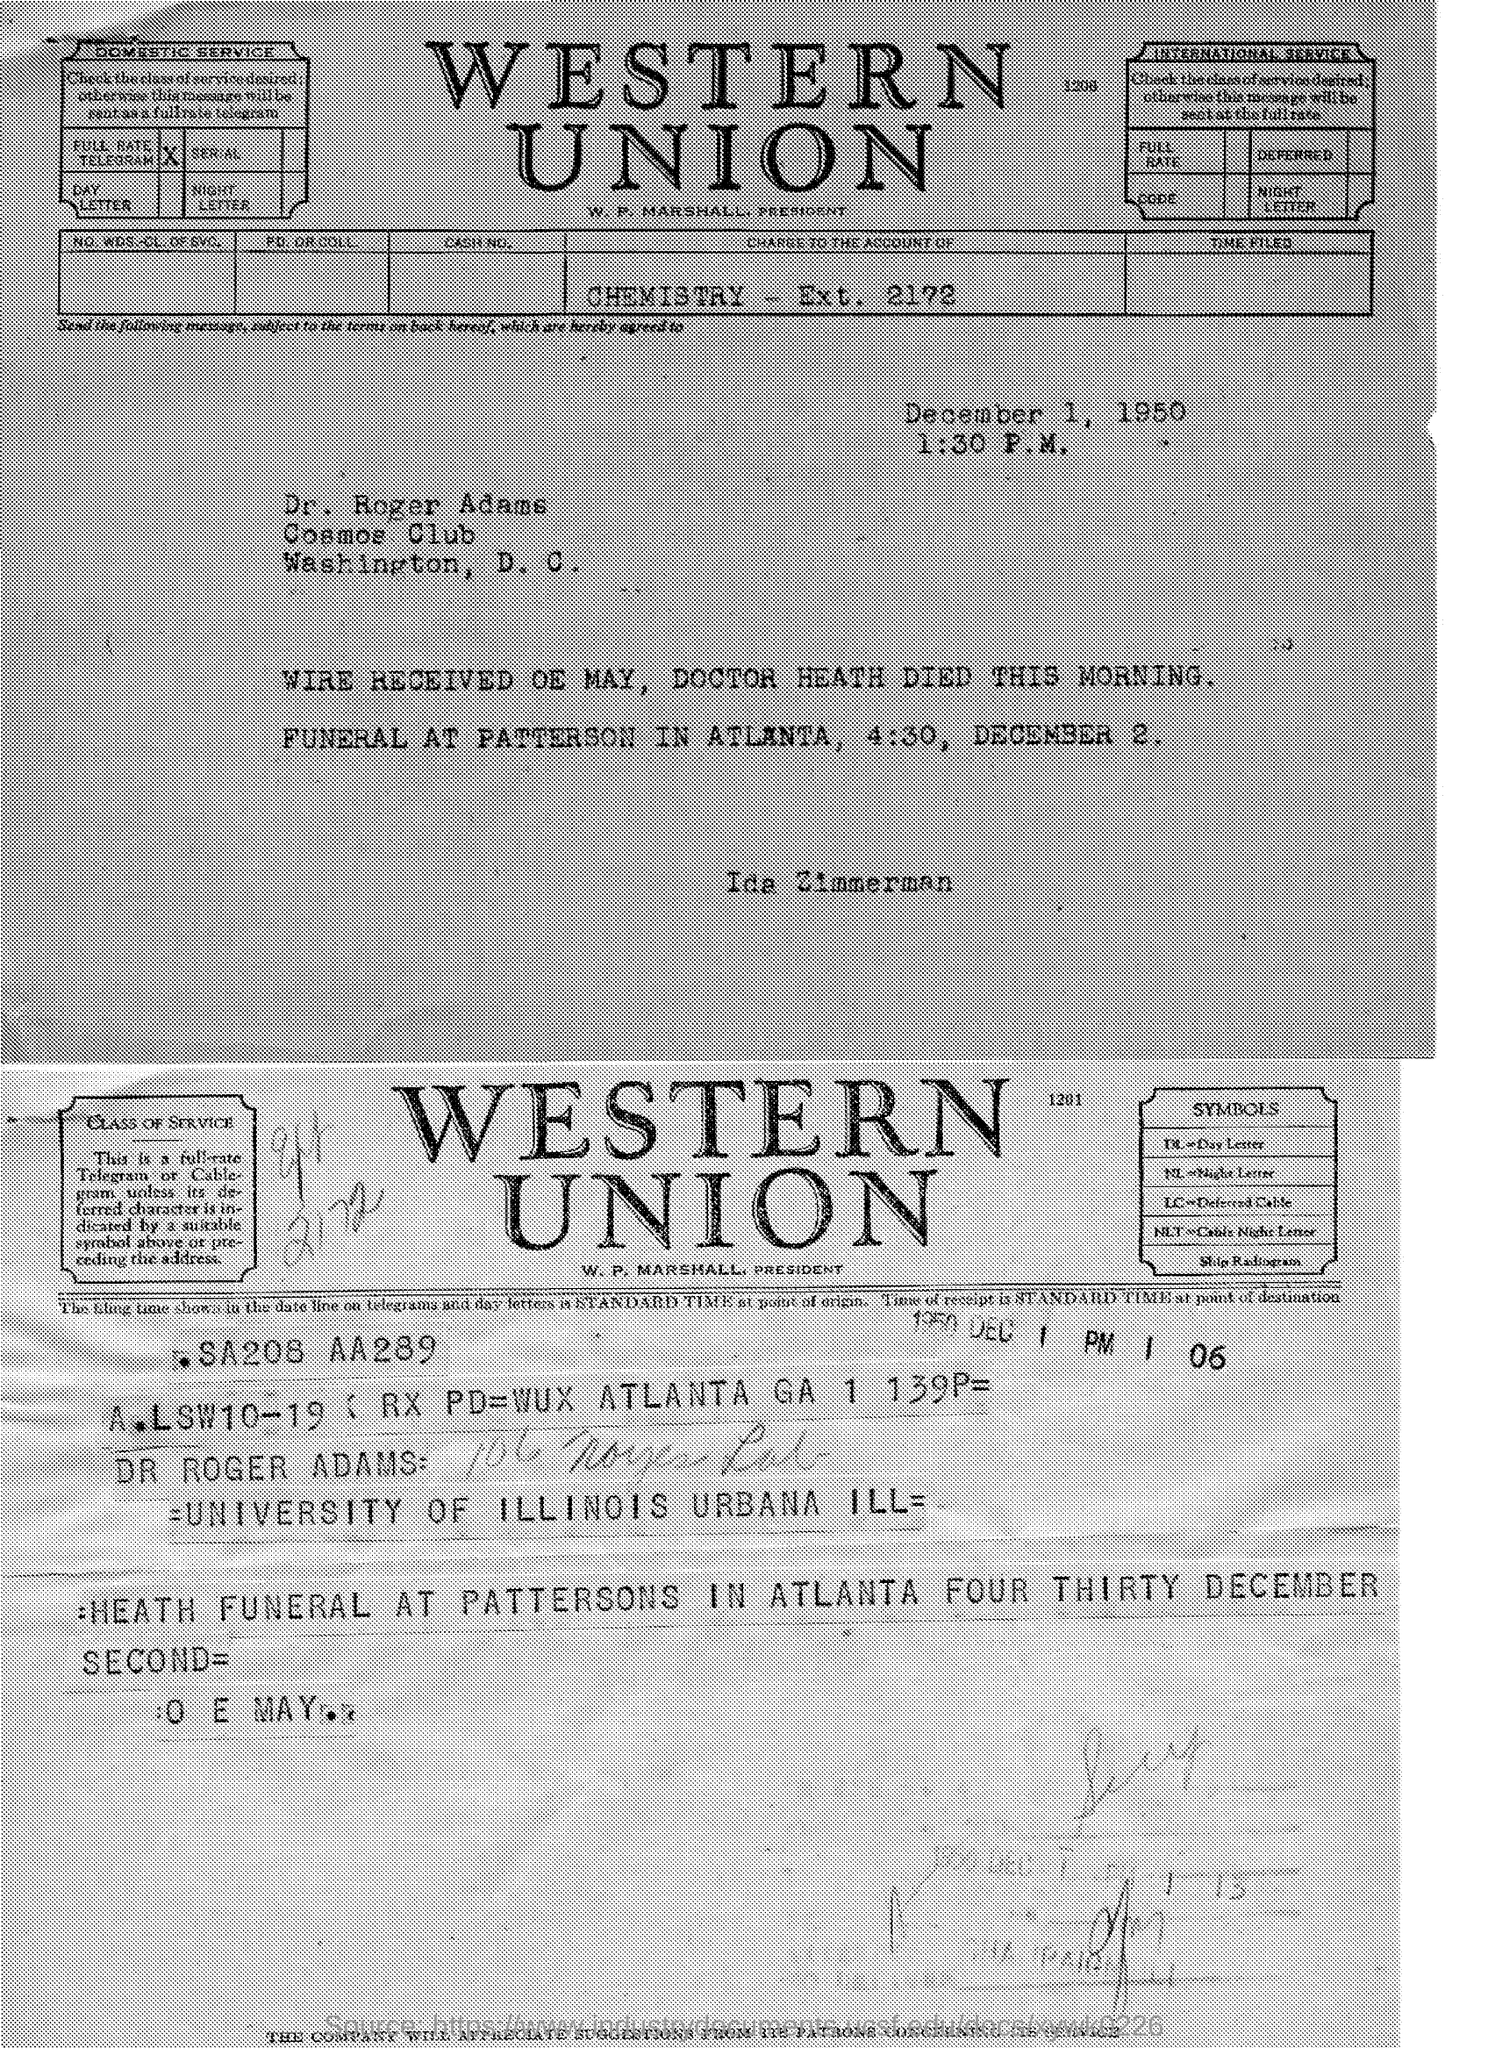Mention a couple of crucial points in this snapshot. The given page mentions a date for the funeral to be held in December. The funeral is scheduled to begin at 4:30 pm. 